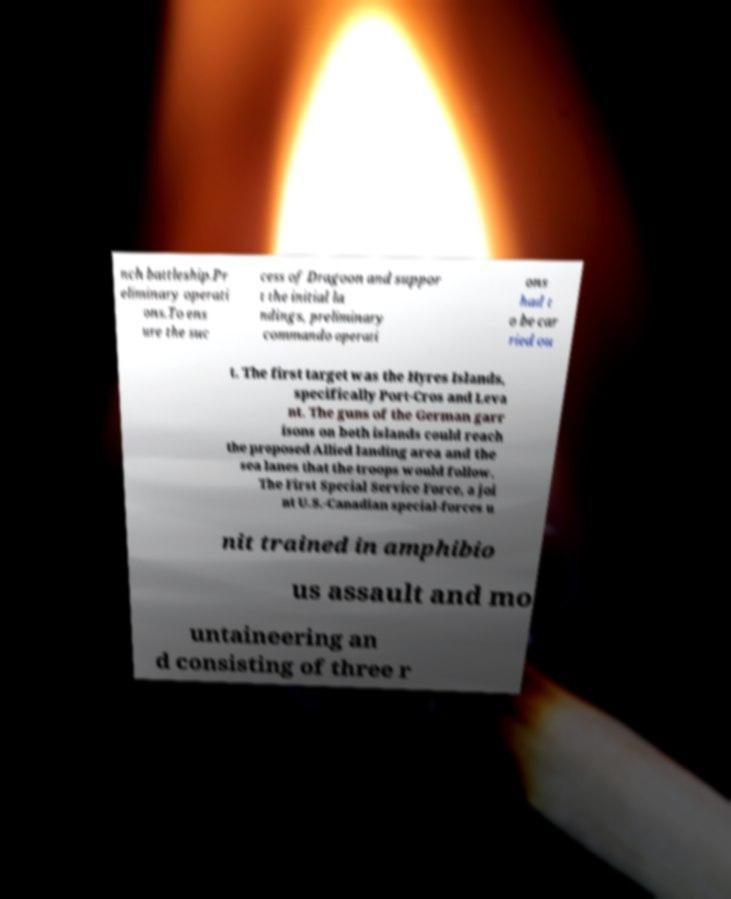For documentation purposes, I need the text within this image transcribed. Could you provide that? nch battleship.Pr eliminary operati ons.To ens ure the suc cess of Dragoon and suppor t the initial la ndings, preliminary commando operati ons had t o be car ried ou t. The first target was the Hyres Islands, specifically Port-Cros and Leva nt. The guns of the German garr isons on both islands could reach the proposed Allied landing area and the sea lanes that the troops would follow. The First Special Service Force, a joi nt U.S.-Canadian special-forces u nit trained in amphibio us assault and mo untaineering an d consisting of three r 